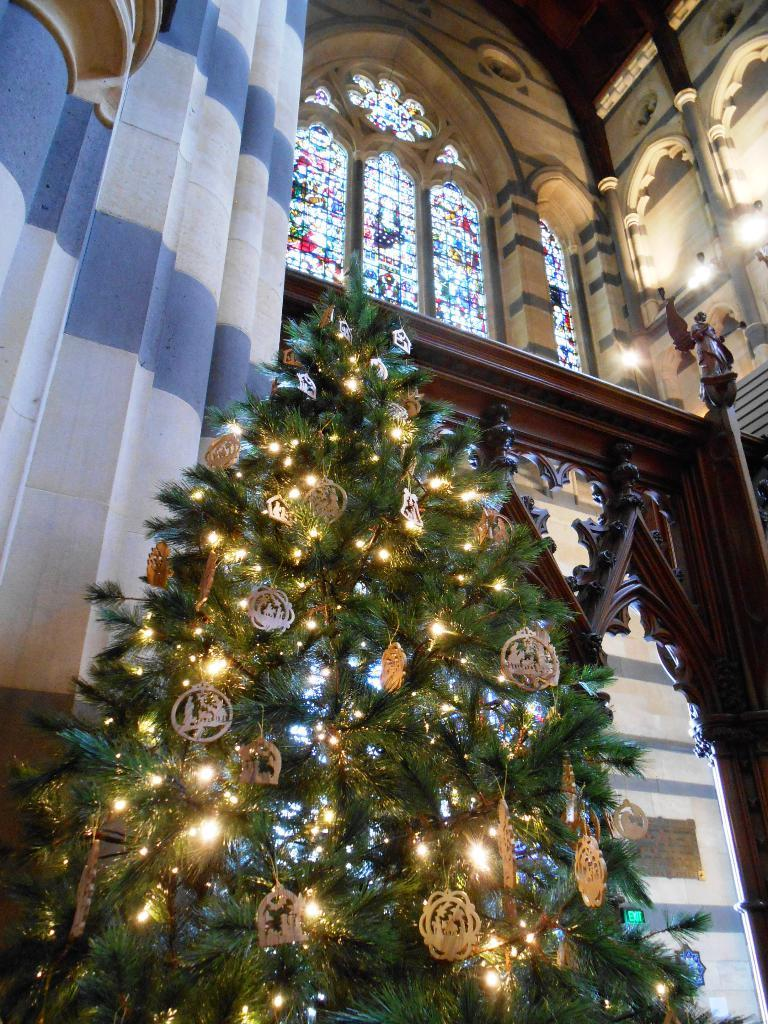What is the main object in the foreground of the image? There is a Xmas tree in the foreground of the image. What can be seen in the background of the image? There is a wall, lights, a wooden structure, and glass windows in the background of the image. Can you describe the wooden structure in the background? The wooden structure in the background is not described in the provided facts, so we cannot provide a detailed answer. How does the crate affect the stability of the Xmas tree in the image? There is no crate present in the image, so it cannot affect the stability of the Xmas tree. Is there any evidence of an earthquake or volleyball game in the image? There is no mention of an earthquake or volleyball game in the provided facts, so we cannot determine if they are present in the image. 